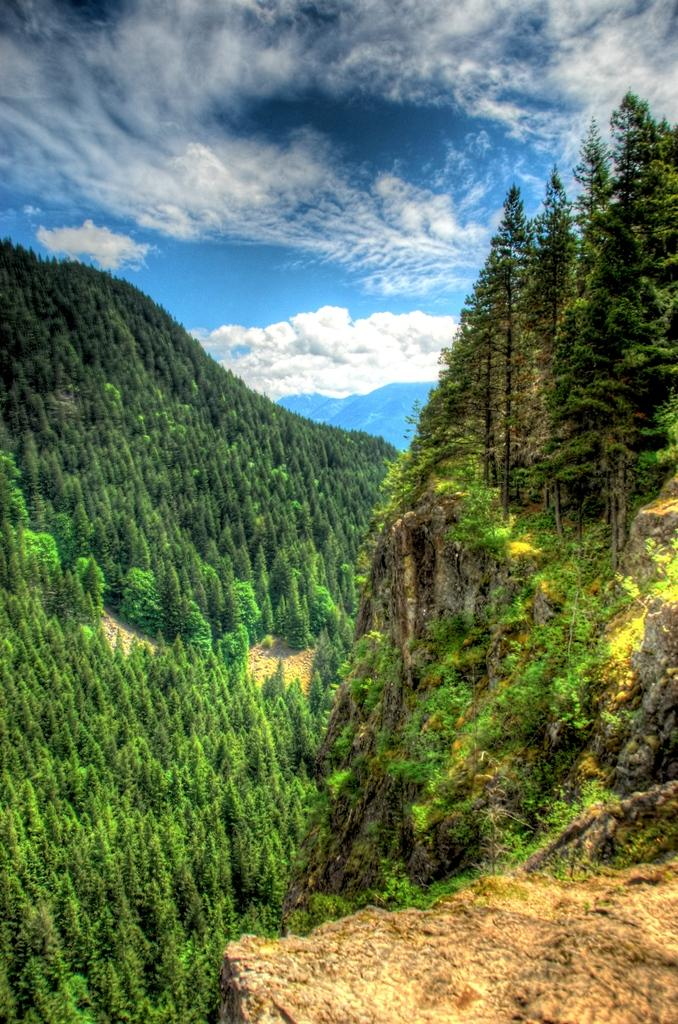What type of vegetation can be seen in the image? There are green color trees in the image. What other object is present in the image besides the trees? There is a rock in the image. How would you describe the color of the sky in the image? The sky is a combination of white and blue colors. Where is the gun placed in the image? There is no gun present in the image. What type of linen can be seen hanging from the trees in the image? There are no linens hanging from the trees in the image; it only features green color trees and a rock. 